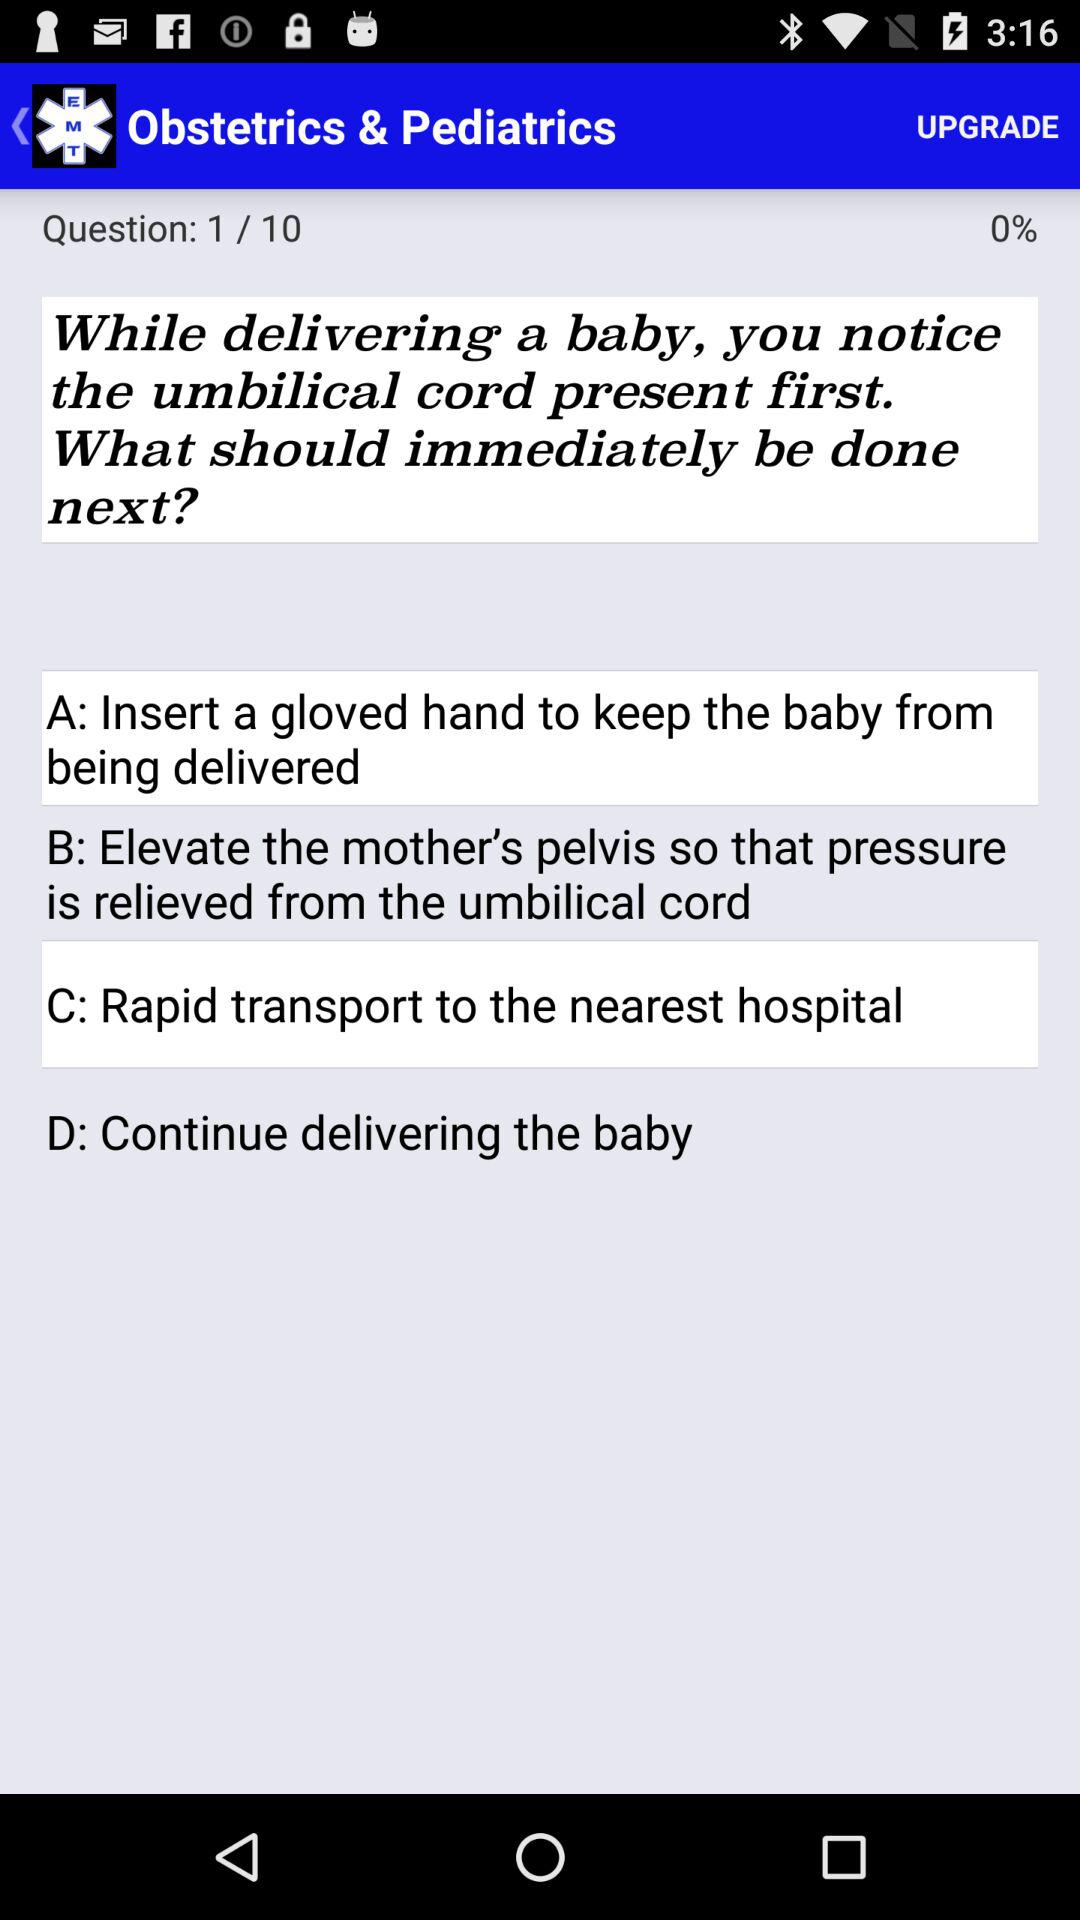Which options are selected from answer choices given?
When the provided information is insufficient, respond with <no answer>. <no answer> 